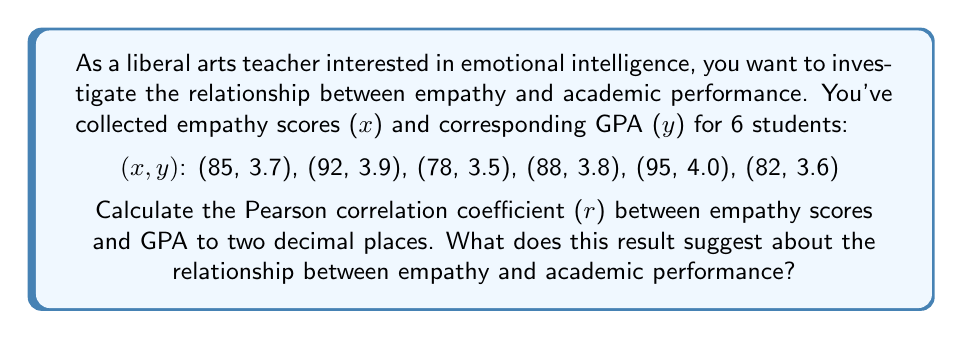Give your solution to this math problem. To calculate the Pearson correlation coefficient (r), we'll use the formula:

$$ r = \frac{n\sum xy - \sum x \sum y}{\sqrt{[n\sum x^2 - (\sum x)^2][n\sum y^2 - (\sum y)^2]}} $$

Where n is the number of data points.

Step 1: Calculate the sums and squares:
$\sum x = 85 + 92 + 78 + 88 + 95 + 82 = 520$
$\sum y = 3.7 + 3.9 + 3.5 + 3.8 + 4.0 + 3.6 = 22.5$
$\sum xy = (85 * 3.7) + (92 * 3.9) + ... + (82 * 3.6) = 1960.1$
$\sum x^2 = 85^2 + 92^2 + ... + 82^2 = 45,374$
$\sum y^2 = 3.7^2 + 3.9^2 + ... + 3.6^2 = 84.55$

Step 2: Substitute into the formula:
$$ r = \frac{6(1960.1) - (520)(22.5)}{\sqrt{[6(45,374) - 520^2][6(84.55) - 22.5^2]}} $$

Step 3: Calculate:
$$ r = \frac{11760.6 - 11700}{\sqrt{(272,244 - 270,400)(507.3 - 506.25)}} $$
$$ r = \frac{60.6}{\sqrt{1844 * 1.05}} $$
$$ r = \frac{60.6}{44.04} $$
$$ r \approx 0.98 $$

The Pearson correlation coefficient of 0.98 suggests a very strong positive correlation between empathy scores and academic performance (GPA). This indicates that as empathy scores increase, there is a strong tendency for GPA to increase as well.
Answer: r ≈ 0.98 (strong positive correlation) 